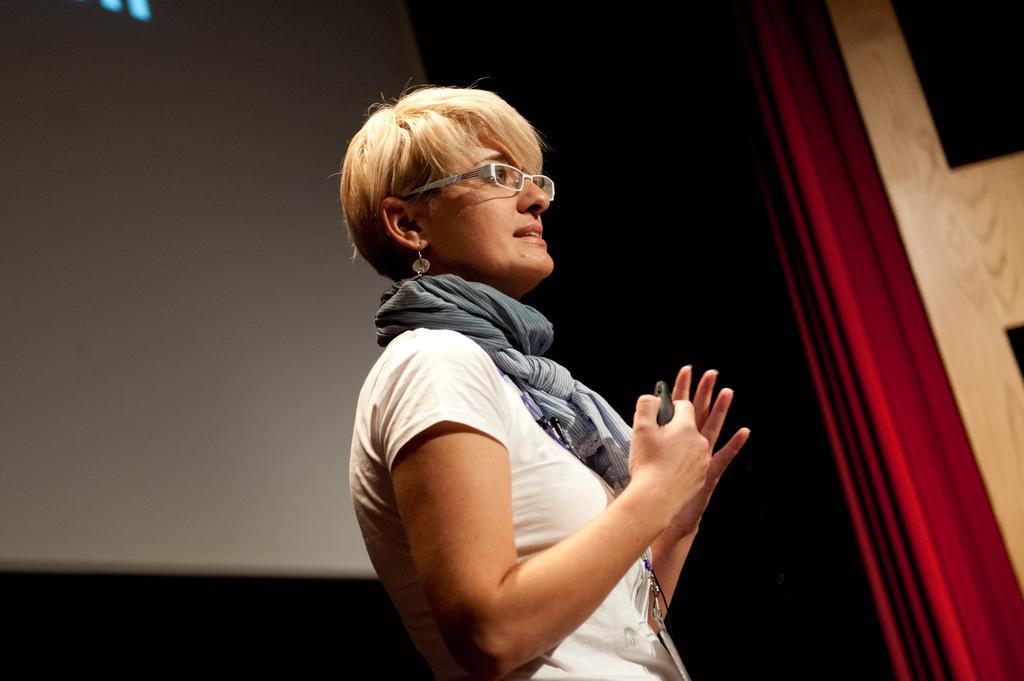Can you describe this image briefly? A beautiful woman is standing, she wore white color dress and spectacles. 